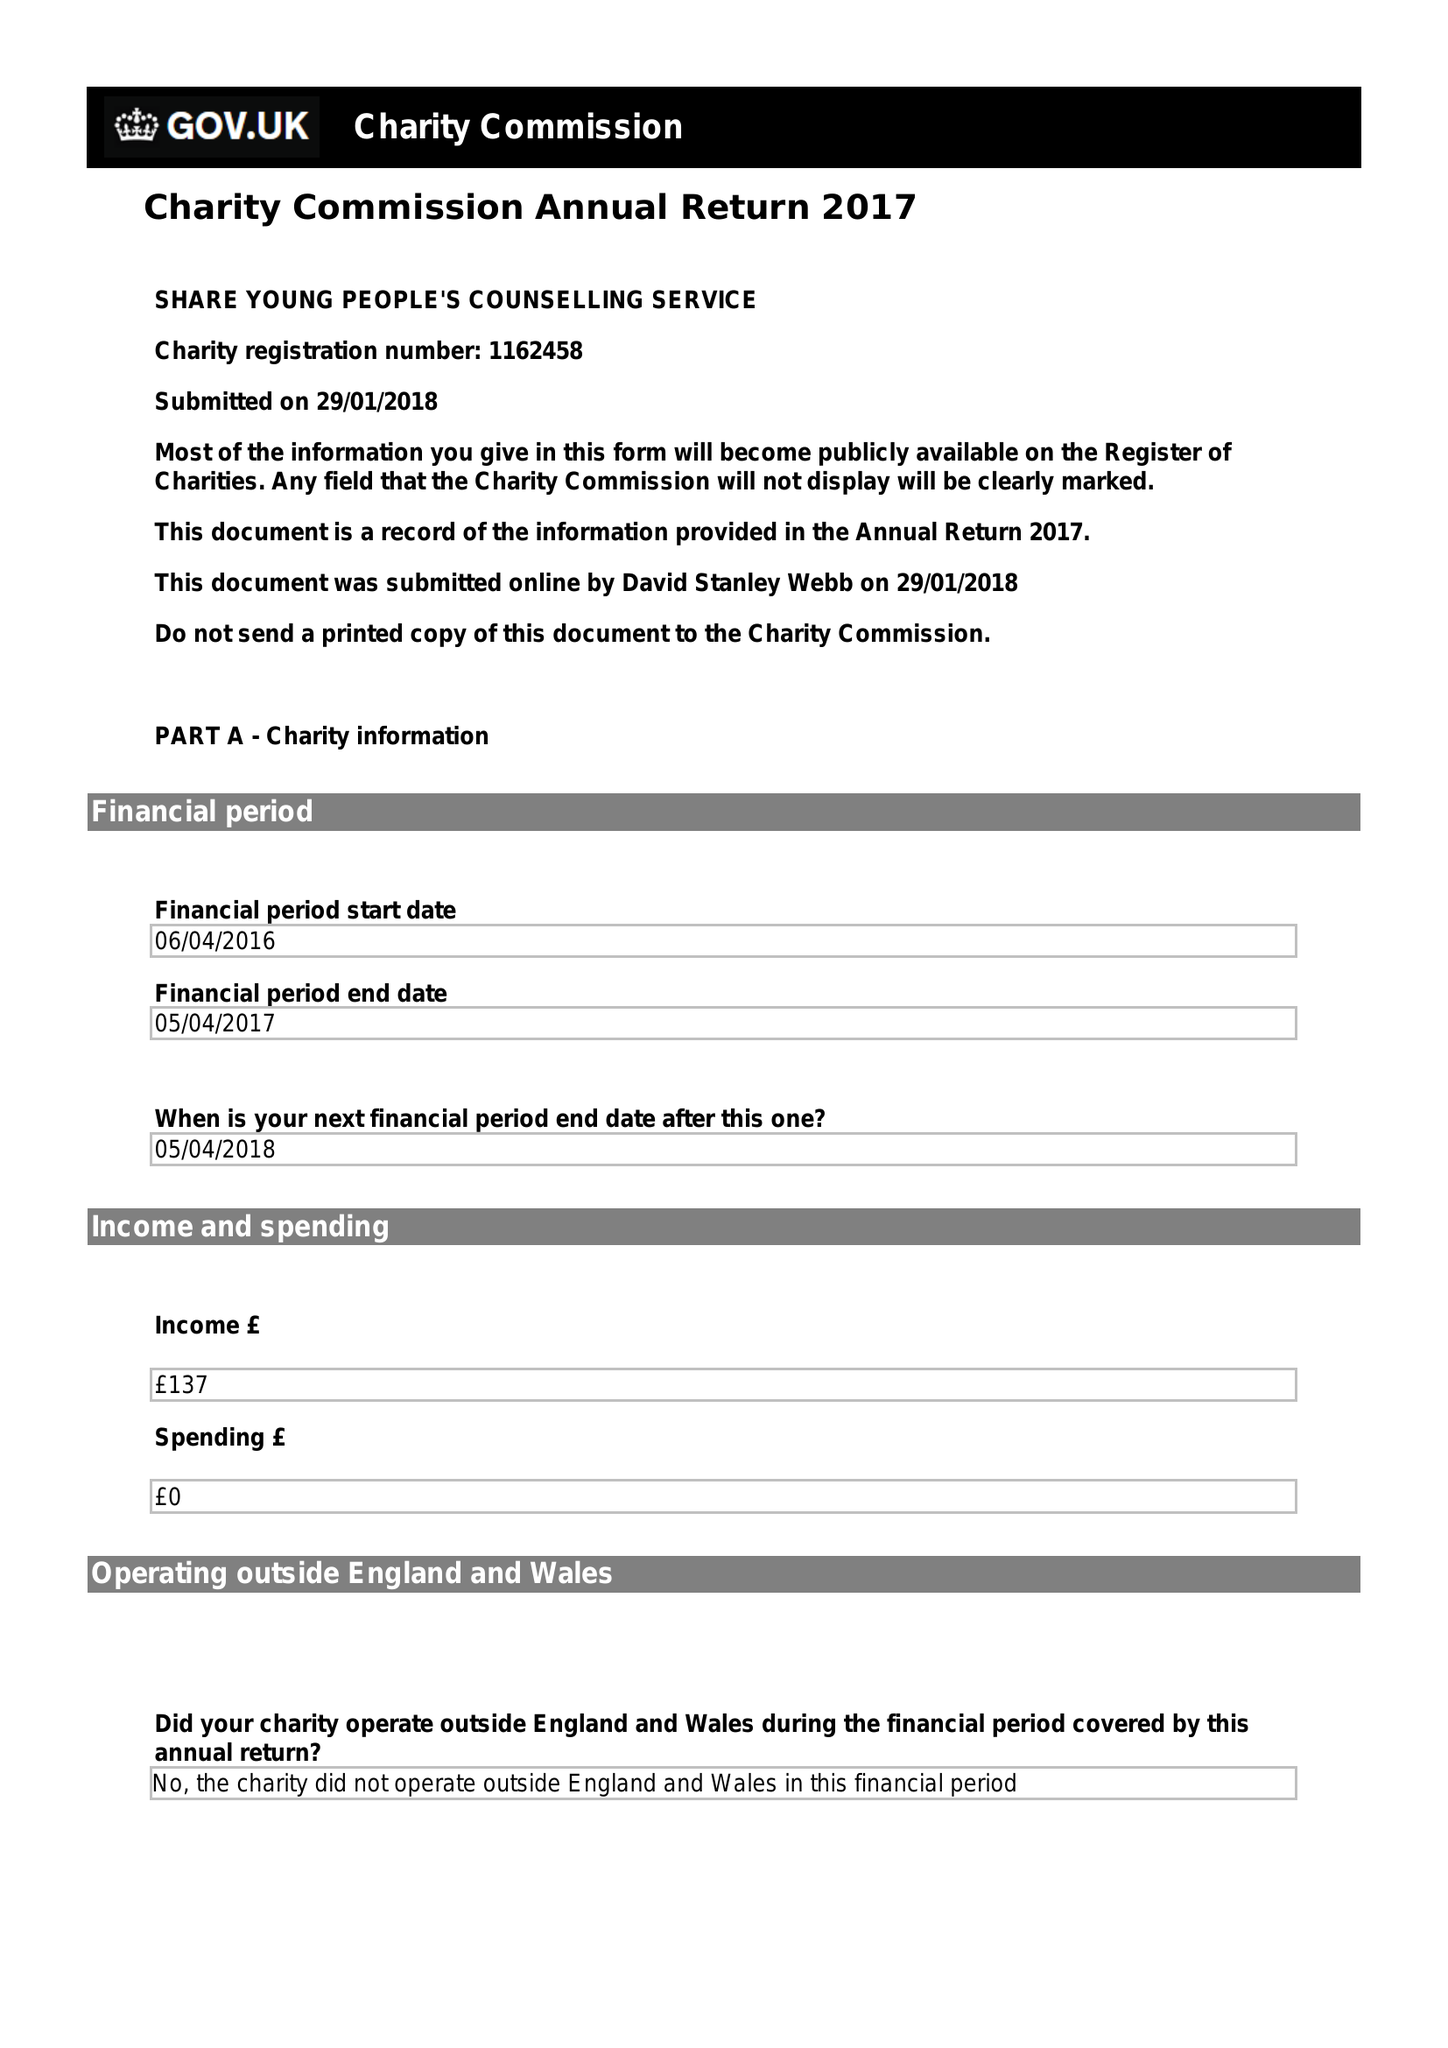What is the value for the report_date?
Answer the question using a single word or phrase. 2017-04-05 